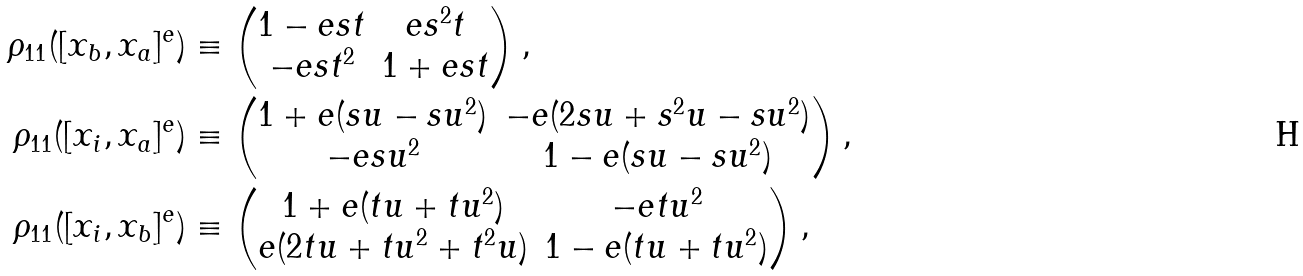<formula> <loc_0><loc_0><loc_500><loc_500>\rho _ { 1 1 } ( [ x _ { b } , x _ { a } ] ^ { e } ) & \equiv \begin{pmatrix} 1 - e s t & e s ^ { 2 } t \\ - e s t ^ { 2 } & 1 + e s t \end{pmatrix} , \\ \rho _ { 1 1 } ( [ x _ { i } , x _ { a } ] ^ { e } ) & \equiv \begin{pmatrix} 1 + e ( s u - s u ^ { 2 } ) & - e ( 2 s u + s ^ { 2 } u - s u ^ { 2 } ) \\ - e s u ^ { 2 } & 1 - e ( s u - s u ^ { 2 } ) \end{pmatrix} , \\ \rho _ { 1 1 } ( [ x _ { i } , x _ { b } ] ^ { e } ) & \equiv \begin{pmatrix} 1 + e ( t u + t u ^ { 2 } ) & - e t u ^ { 2 } \\ e ( 2 t u + t u ^ { 2 } + t ^ { 2 } u ) & 1 - e ( t u + t u ^ { 2 } ) \end{pmatrix} ,</formula> 